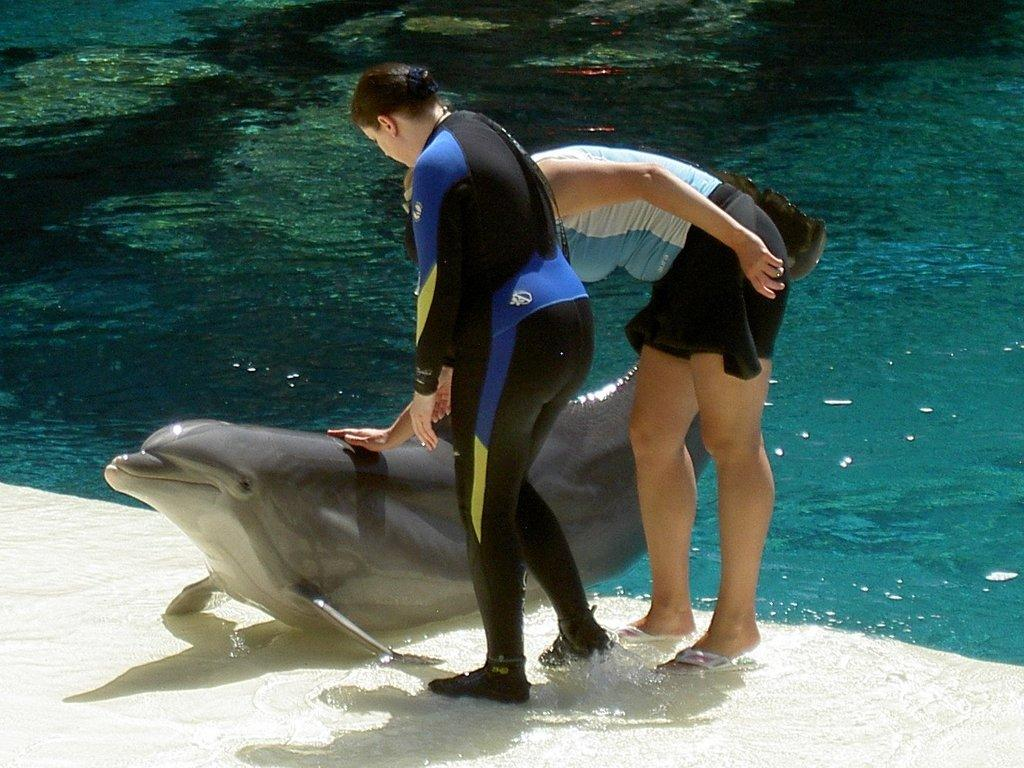Who or what can be seen in the image? There are people and a dolphin in the image. Where are the people and dolphin located? They are on the water surface in the image. What is the surrounding environment like? There is water visible in the image, and the bottom appears to be a sand floor. What type of station can be seen in the image? There is no station present in the image. Is the water in the image hot or cold? The provided facts do not mention the temperature of the water, so it cannot be determined from the image. 